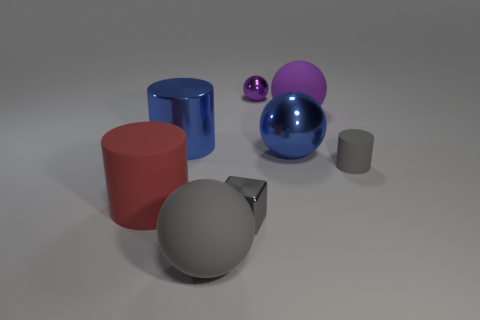There is a big metal sphere; is its color the same as the large cylinder right of the red matte thing?
Offer a terse response. Yes. There is a gray matte thing that is behind the large rubber cylinder; how many gray objects are to the left of it?
Offer a terse response. 2. There is a large metal thing on the left side of the big ball in front of the tiny gray metal object; what is its color?
Offer a very short reply. Blue. There is a object that is on the left side of the big gray matte sphere and behind the gray cylinder; what material is it made of?
Offer a very short reply. Metal. Are there any other rubber objects of the same shape as the big gray thing?
Make the answer very short. Yes. Does the large matte thing behind the large metal ball have the same shape as the tiny purple shiny thing?
Provide a succinct answer. Yes. How many gray rubber objects are both behind the block and to the left of the big metal ball?
Your answer should be very brief. 0. There is a large matte thing that is on the left side of the big blue cylinder; what is its shape?
Ensure brevity in your answer.  Cylinder. What number of big blue spheres have the same material as the tiny ball?
Provide a short and direct response. 1. Do the purple rubber object and the large matte object in front of the small gray block have the same shape?
Offer a terse response. Yes. 